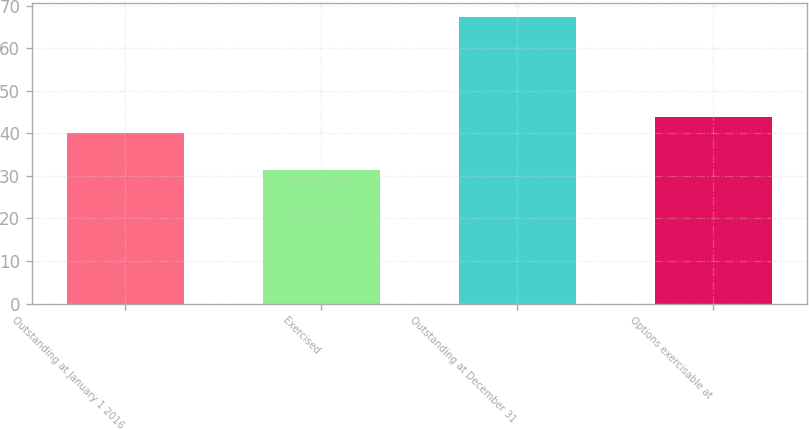Convert chart. <chart><loc_0><loc_0><loc_500><loc_500><bar_chart><fcel>Outstanding at January 1 2016<fcel>Exercised<fcel>Outstanding at December 31<fcel>Options exercisable at<nl><fcel>40.17<fcel>31.47<fcel>67.27<fcel>43.75<nl></chart> 